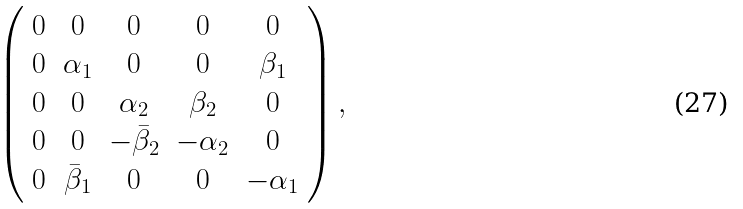Convert formula to latex. <formula><loc_0><loc_0><loc_500><loc_500>\left ( \begin{array} { c c c c c } 0 & 0 & 0 & 0 & 0 \\ 0 & \alpha _ { 1 } & 0 & 0 & \beta _ { 1 } \\ 0 & 0 & \alpha _ { 2 } & \beta _ { 2 } & 0 \\ 0 & 0 & - { \bar { \beta } } _ { 2 } & - \alpha _ { 2 } & 0 \\ 0 & { \bar { \beta } } _ { 1 } & 0 & 0 & - \alpha _ { 1 } \end{array} \right ) ,</formula> 